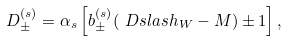<formula> <loc_0><loc_0><loc_500><loc_500>D _ { \pm } ^ { ( s ) } = \alpha _ { s } \left [ b _ { \pm } ^ { ( s ) } ( \ D s l a s h _ { W } - M ) \pm 1 \right ] ,</formula> 